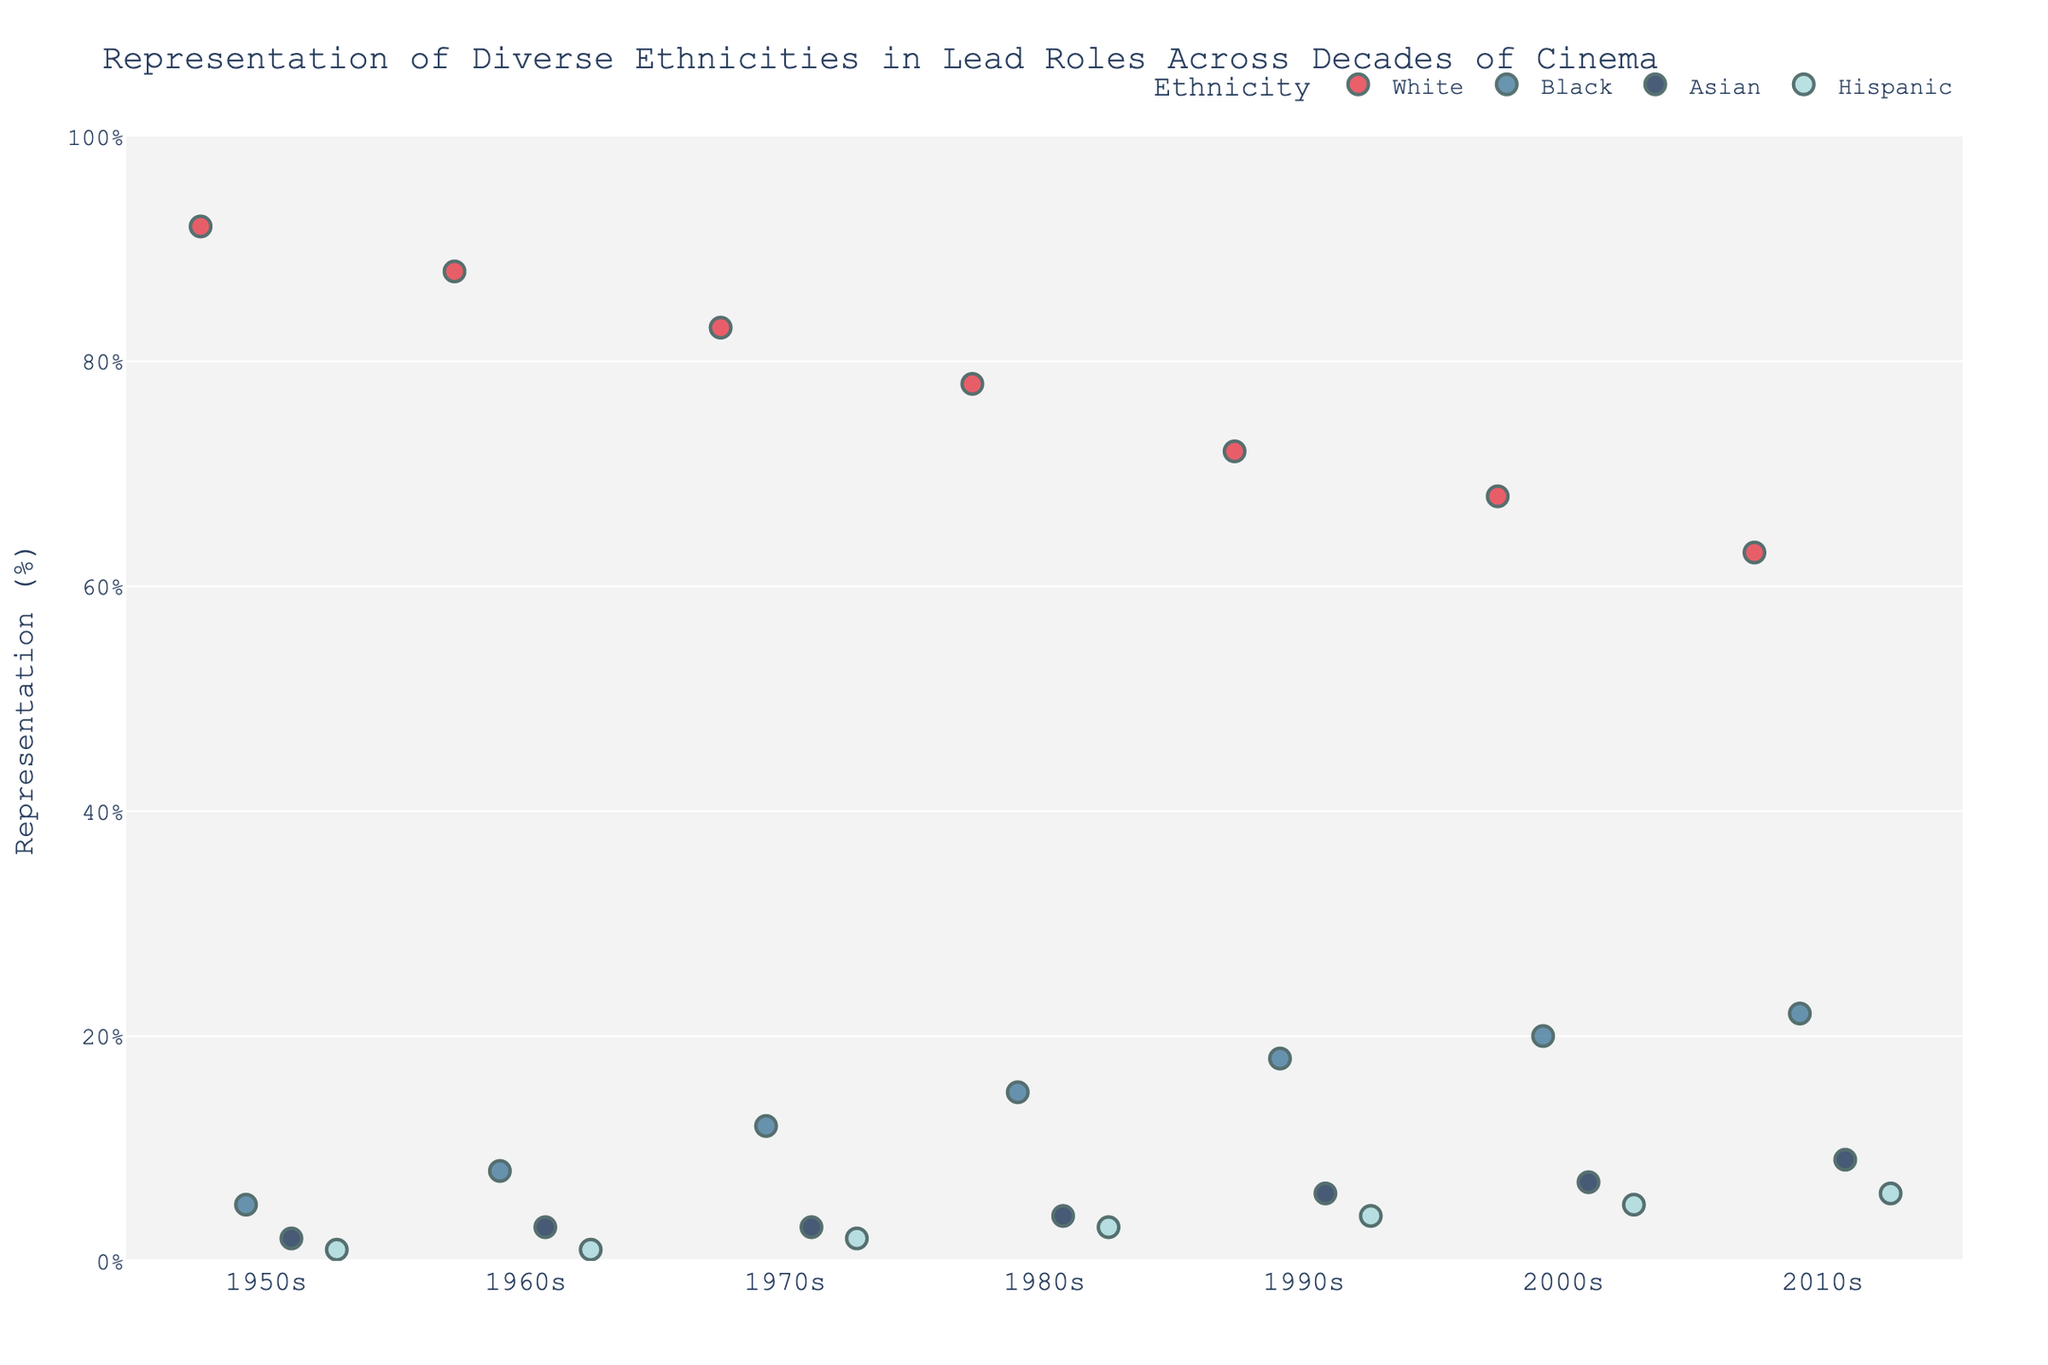What's the title of the plot? The title is displayed at the top of the figure and gives a brief description of what the plot represents.
Answer: Representation of Diverse Ethnicities in Lead Roles Across Decades of Cinema Which ethnicity had the highest percentage in the 1950s? By observing the 1950s group on the x-axis and identifying the highest data point.
Answer: White How has the percentage of Black lead roles changed from the 1950s to the 2010s? Compare the Black percentage in the 1950s to the percentage in the 2010s.
Answer: It increased from 5% to 22% What was the percentage of Hispanic lead roles in the 1990s? Navigate to the 1990s group on the x-axis and find the percentage for Hispanic.
Answer: 4% Which decade shows the greatest representation of Asian lead roles? Look across all decades on the x-axis and identify the highest percentage value for Asian.
Answer: 2010s How does the representation of White lead roles in the 2000s compare with the 2010s? Compare the percentage values for White in both decades.
Answer: It decreased from 68% to 63% What is the overall trend for the representation of White lead roles from the 1950s to the 2010s? Observe the percentage values for White across all decades and describe the trend.
Answer: A consistent decline Calculate the average percentage of Black lead roles from the 1980s to the 2010s. Sum the percentages for Black in the 1980s, 1990s, 2000s, and 2010s, then divide by 4. (15 + 18 + 20 + 22)/4 = 18.75
Answer: 18.75 Which ethnicity saw the most significant increase in representation from the 1950s to the 2010s? Compare the percentage differences for each ethnicity between the 1950s and the 2010s to find the largest increase.
Answer: Black What is the color used to represent Hispanic roles in the plot? Identify the color corresponding to the label 'Hispanic' in the legend.
Answer: Light blue 